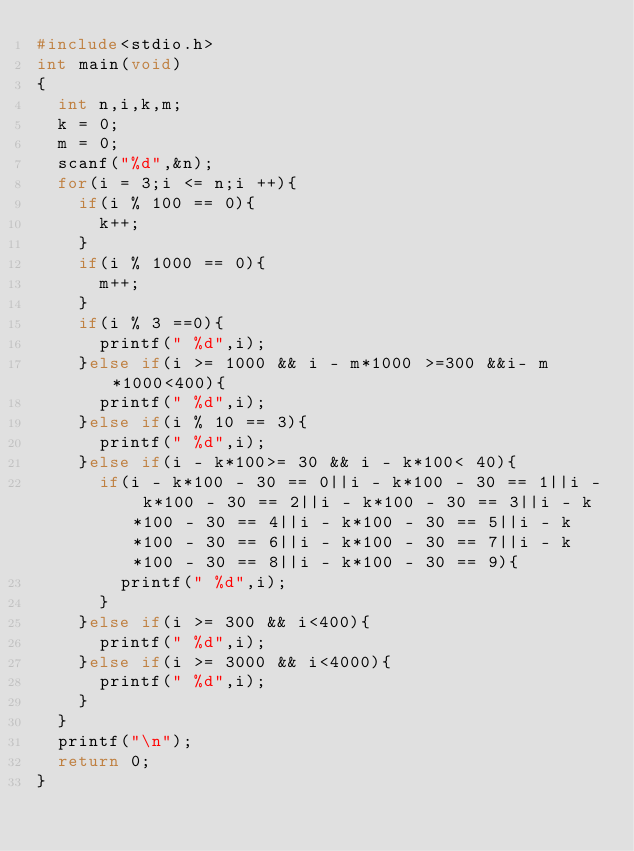Convert code to text. <code><loc_0><loc_0><loc_500><loc_500><_C_>#include<stdio.h>
int main(void)
{
  int n,i,k,m;
  k = 0;
  m = 0;
  scanf("%d",&n);
  for(i = 3;i <= n;i ++){
    if(i % 100 == 0){
      k++;
    }
    if(i % 1000 == 0){
      m++;
    }
    if(i % 3 ==0){
      printf(" %d",i);
    }else if(i >= 1000 && i - m*1000 >=300 &&i- m*1000<400){
      printf(" %d",i);
    }else if(i % 10 == 3){
      printf(" %d",i);
    }else if(i - k*100>= 30 && i - k*100< 40){
      if(i - k*100 - 30 == 0||i - k*100 - 30 == 1||i - k*100 - 30 == 2||i - k*100 - 30 == 3||i - k*100 - 30 == 4||i - k*100 - 30 == 5||i - k*100 - 30 == 6||i - k*100 - 30 == 7||i - k*100 - 30 == 8||i - k*100 - 30 == 9){
        printf(" %d",i);
      }
    }else if(i >= 300 && i<400){
      printf(" %d",i);
    }else if(i >= 3000 && i<4000){
      printf(" %d",i);
    }
  }
  printf("\n");
  return 0;
}</code> 